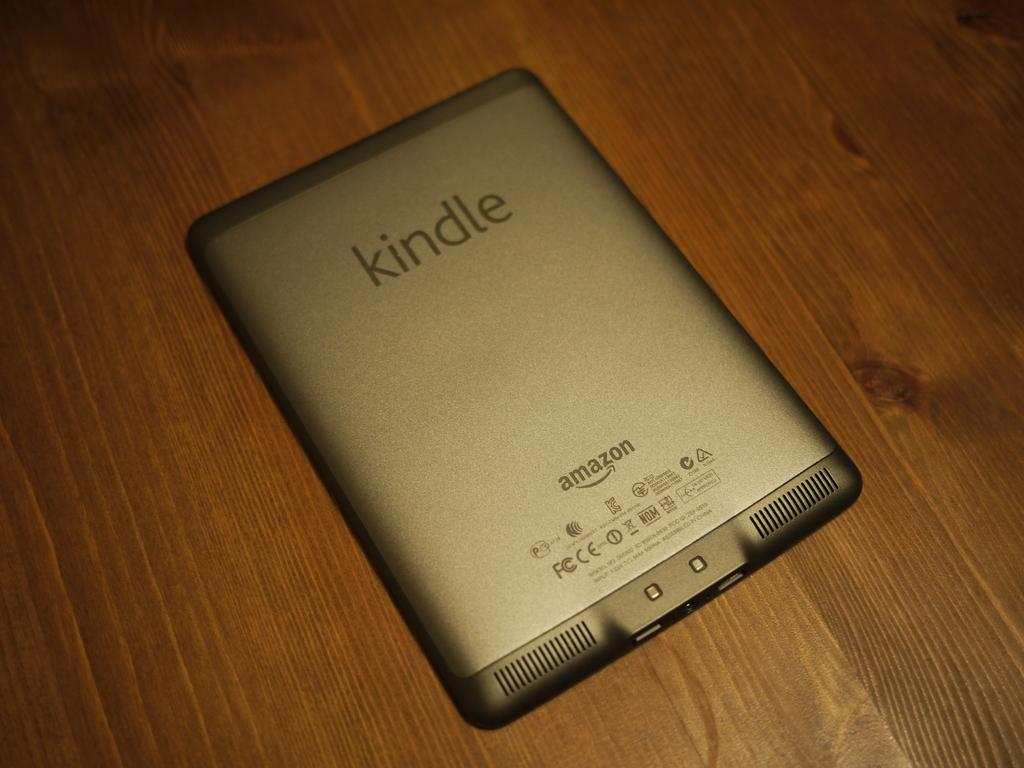Provide a one-sentence caption for the provided image. The silver tablet here is an Amazon Kindle. 